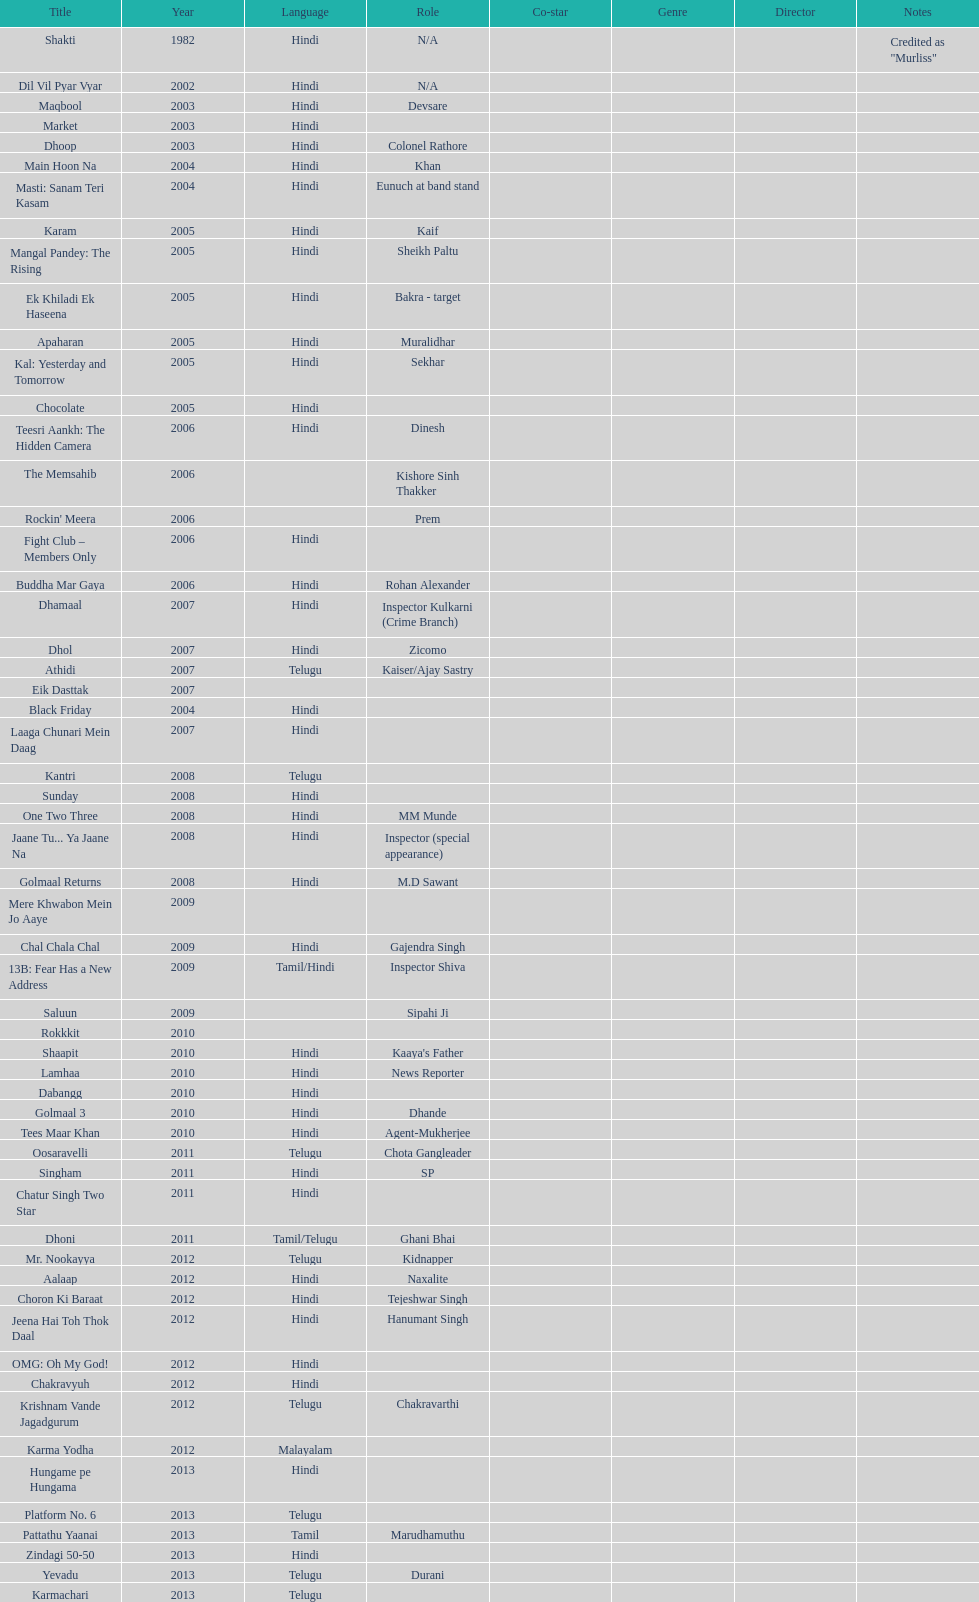What movie did this actor star in after they starred in dil vil pyar vyar in 2002? Maqbool. 